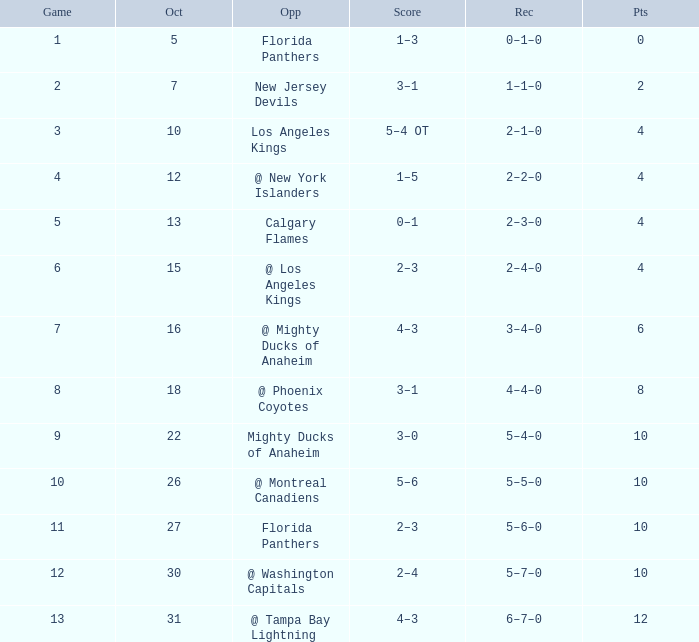What team has a score of 11 5–6–0. 